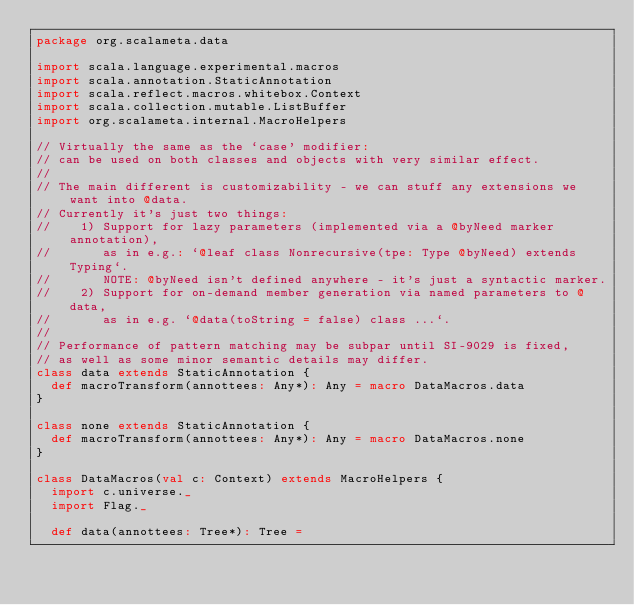Convert code to text. <code><loc_0><loc_0><loc_500><loc_500><_Scala_>package org.scalameta.data

import scala.language.experimental.macros
import scala.annotation.StaticAnnotation
import scala.reflect.macros.whitebox.Context
import scala.collection.mutable.ListBuffer
import org.scalameta.internal.MacroHelpers

// Virtually the same as the `case' modifier:
// can be used on both classes and objects with very similar effect.
//
// The main different is customizability - we can stuff any extensions we want into @data.
// Currently it's just two things:
//    1) Support for lazy parameters (implemented via a @byNeed marker annotation),
//       as in e.g.: `@leaf class Nonrecursive(tpe: Type @byNeed) extends Typing`.
//       NOTE: @byNeed isn't defined anywhere - it's just a syntactic marker.
//    2) Support for on-demand member generation via named parameters to @data,
//       as in e.g. `@data(toString = false) class ...`.
//
// Performance of pattern matching may be subpar until SI-9029 is fixed,
// as well as some minor semantic details may differ.
class data extends StaticAnnotation {
  def macroTransform(annottees: Any*): Any = macro DataMacros.data
}

class none extends StaticAnnotation {
  def macroTransform(annottees: Any*): Any = macro DataMacros.none
}

class DataMacros(val c: Context) extends MacroHelpers {
  import c.universe._
  import Flag._

  def data(annottees: Tree*): Tree =</code> 